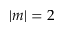<formula> <loc_0><loc_0><loc_500><loc_500>| m | = 2</formula> 